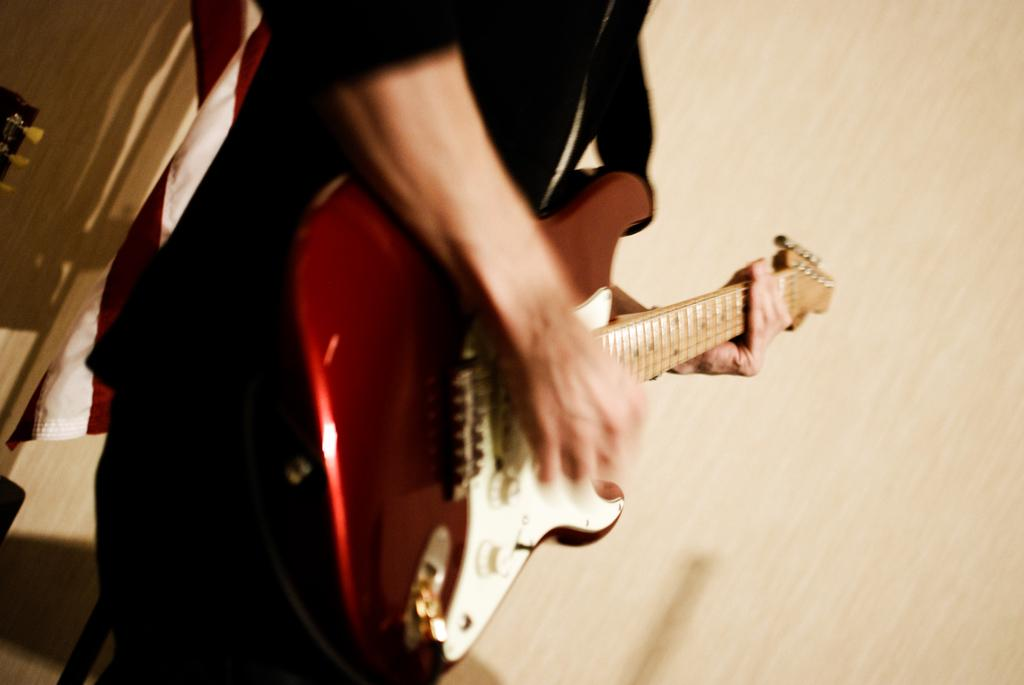What is the main subject of the image? There is a person in the image. What is the person doing in the image? The person is standing and playing a guitar. Can you see a snake slithering around the person's feet in the image? No, there is no snake present in the image. Is the person's family visible in the image? The provided facts do not mention the presence of the person's family, so we cannot determine if they are visible in the image. 